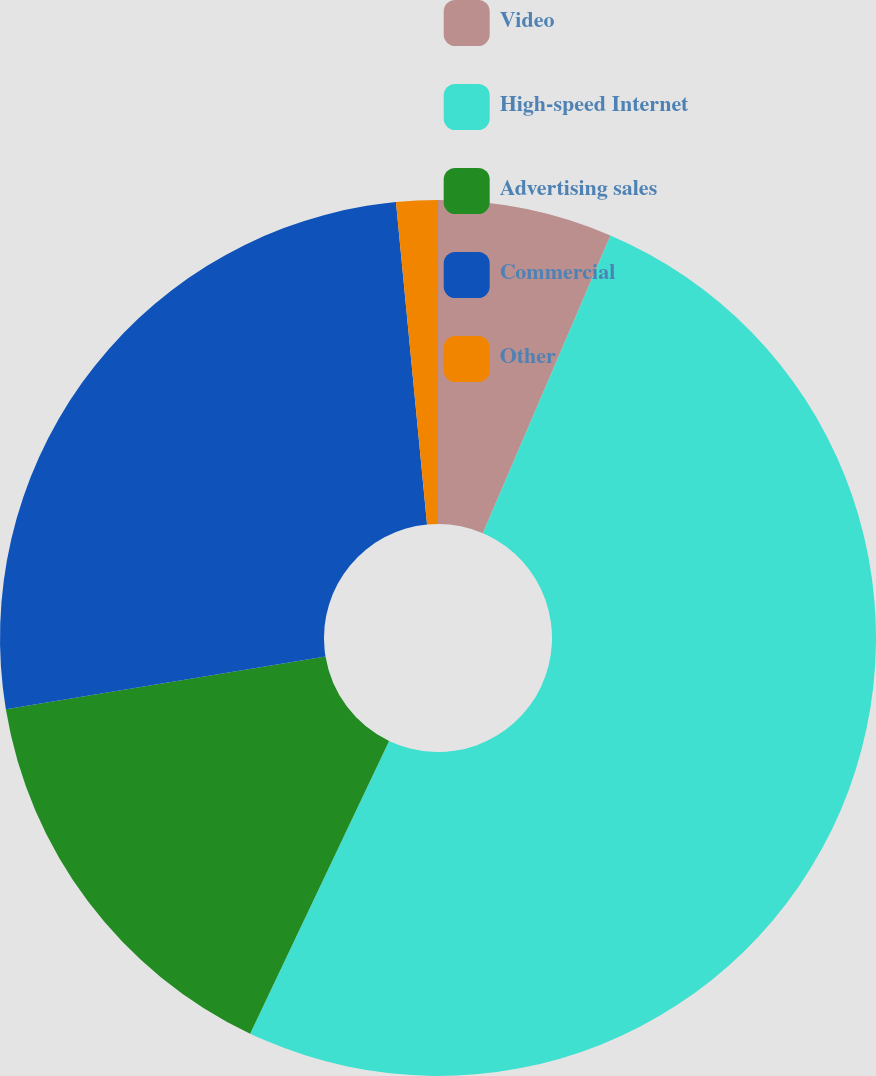Convert chart to OTSL. <chart><loc_0><loc_0><loc_500><loc_500><pie_chart><fcel>Video<fcel>High-speed Internet<fcel>Advertising sales<fcel>Commercial<fcel>Other<nl><fcel>6.44%<fcel>50.61%<fcel>15.34%<fcel>26.07%<fcel>1.53%<nl></chart> 